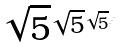Convert formula to latex. <formula><loc_0><loc_0><loc_500><loc_500>\sqrt { 5 } ^ { \sqrt { 5 } ^ { \sqrt { 5 } ^ { \cdot ^ { \cdot ^ { \cdot } } } } }</formula> 